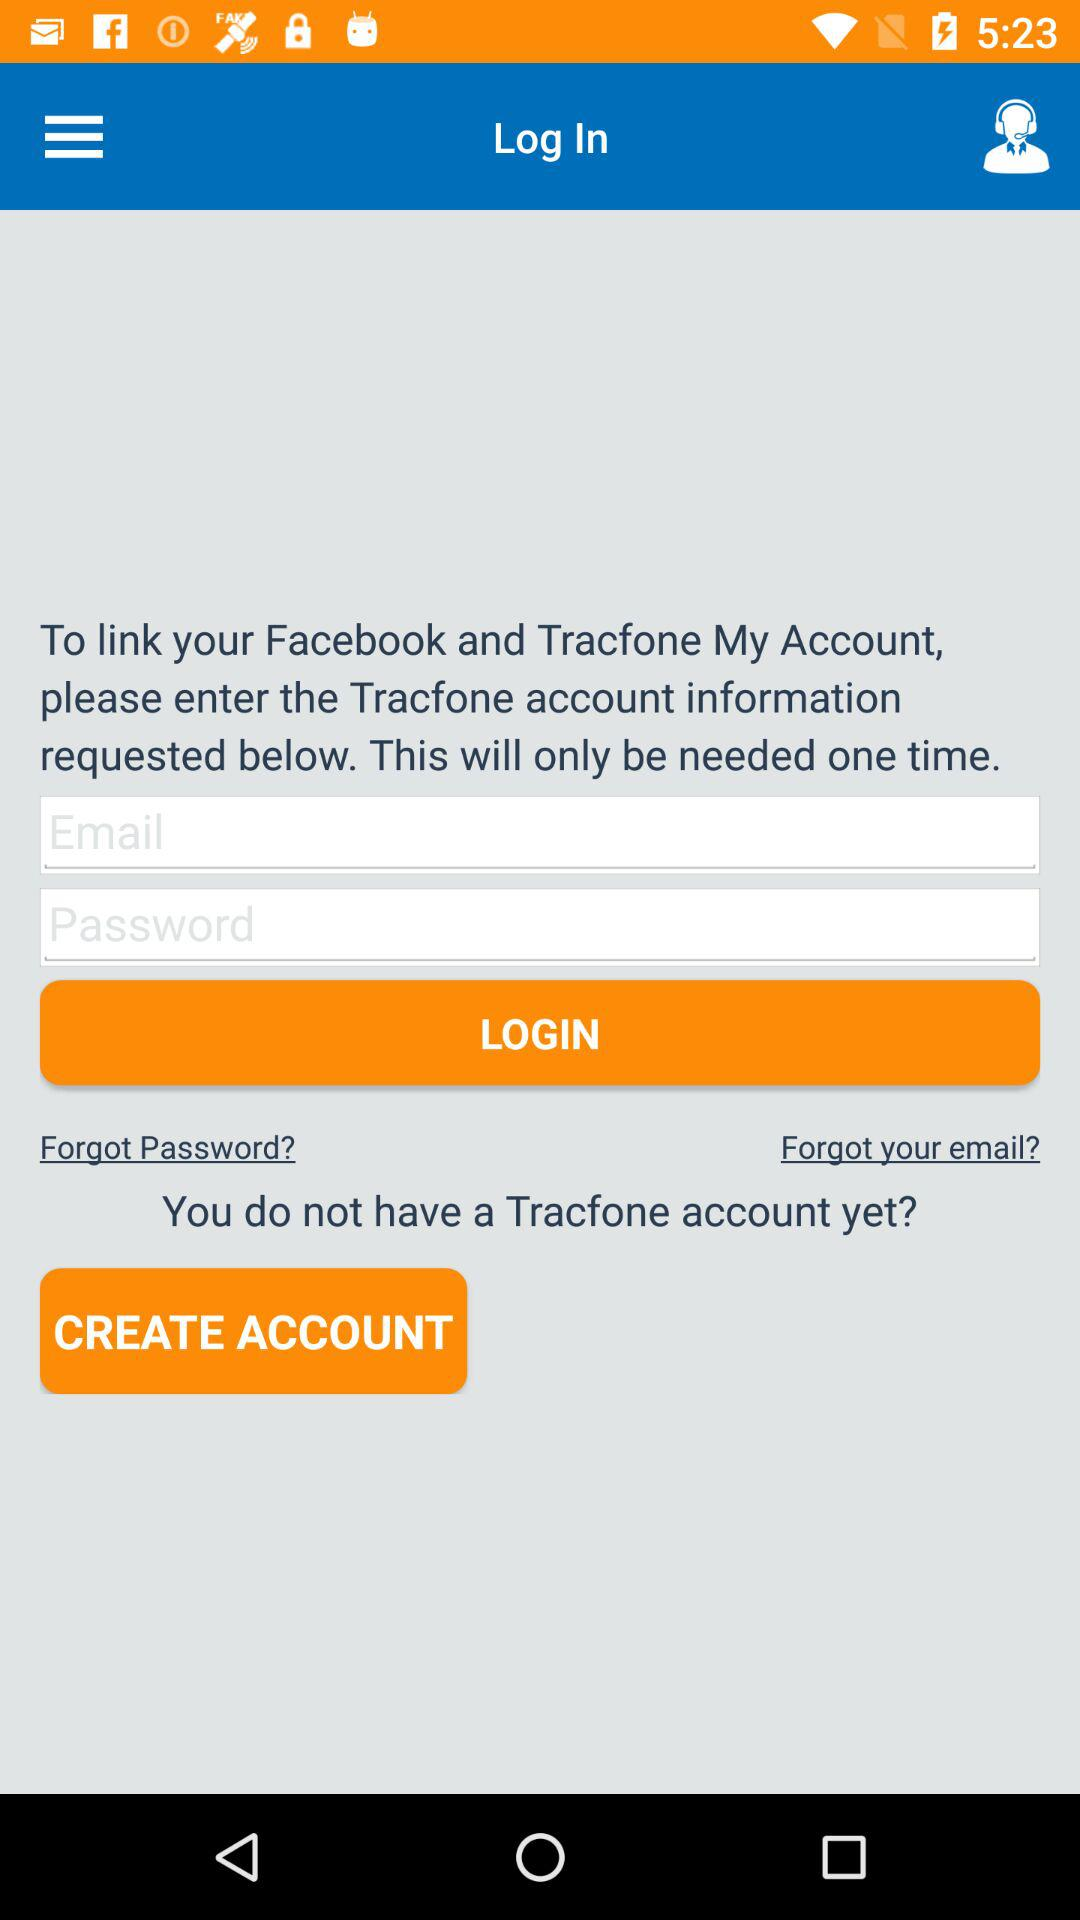How many text inputs are there after the text 'To link your Facebook and Tracfone My Account, please enter the Tracfone account information requested below. This will only be needed one time.'?
Answer the question using a single word or phrase. 2 